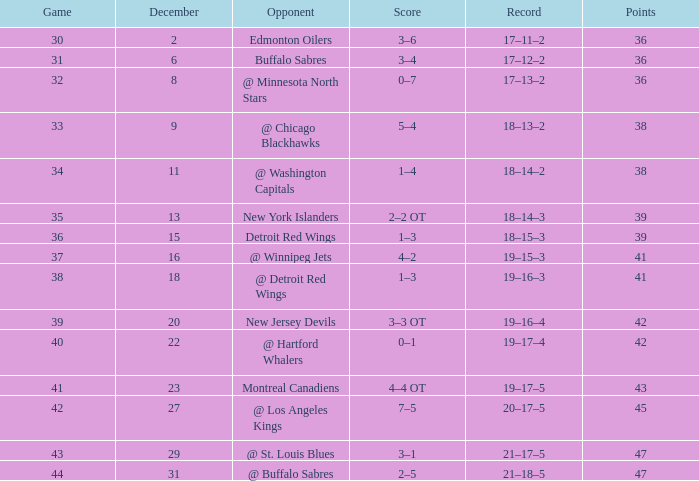What is the score following december 29th? 2–5. 